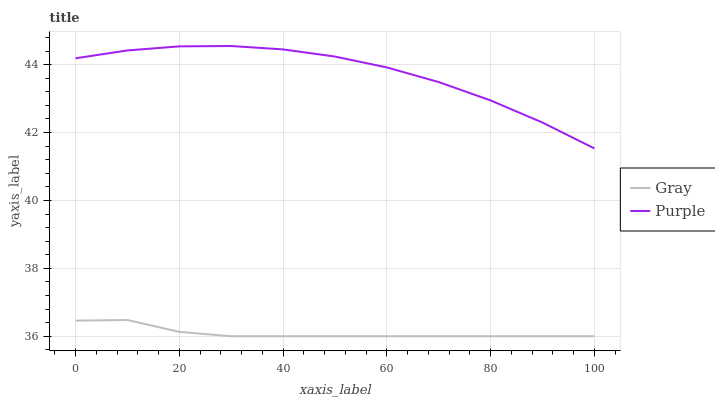Does Gray have the maximum area under the curve?
Answer yes or no. No. Is Gray the roughest?
Answer yes or no. No. Does Gray have the highest value?
Answer yes or no. No. Is Gray less than Purple?
Answer yes or no. Yes. Is Purple greater than Gray?
Answer yes or no. Yes. Does Gray intersect Purple?
Answer yes or no. No. 